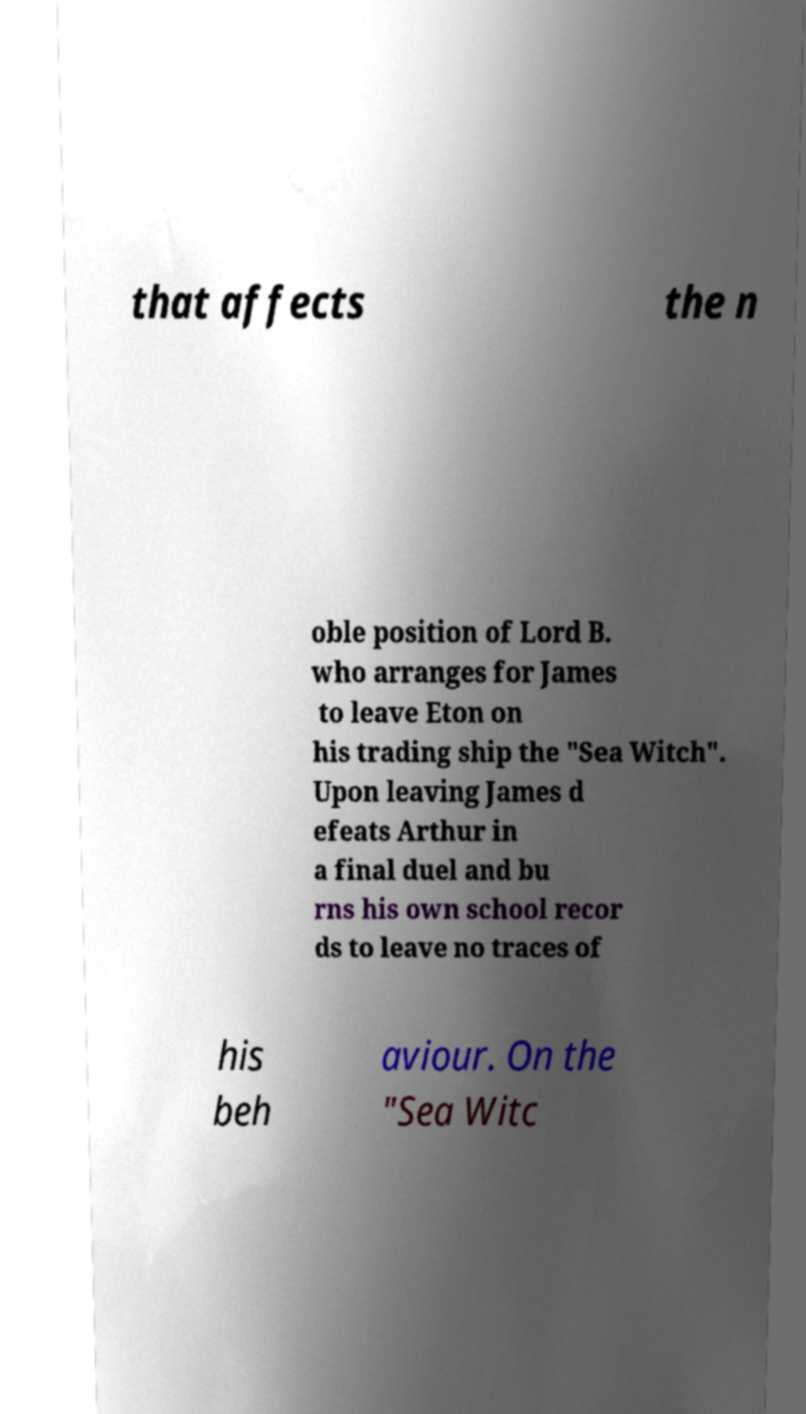Could you extract and type out the text from this image? that affects the n oble position of Lord B. who arranges for James to leave Eton on his trading ship the "Sea Witch". Upon leaving James d efeats Arthur in a final duel and bu rns his own school recor ds to leave no traces of his beh aviour. On the "Sea Witc 